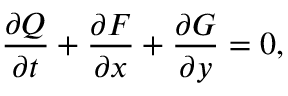<formula> <loc_0><loc_0><loc_500><loc_500>\frac { \partial Q } { \partial t } + \frac { \partial F } { \partial x } + \frac { \partial G } { \partial y } = 0 ,</formula> 